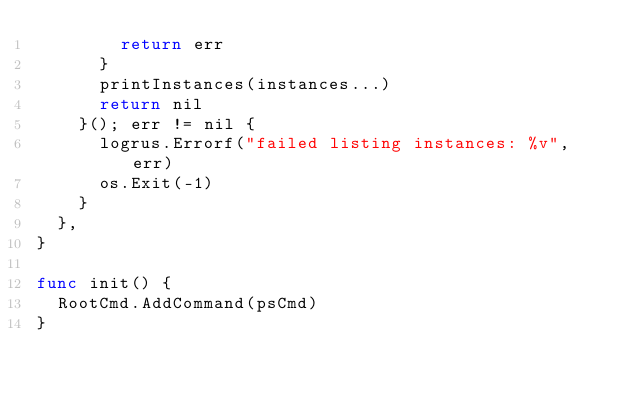<code> <loc_0><loc_0><loc_500><loc_500><_Go_>				return err
			}
			printInstances(instances...)
			return nil
		}(); err != nil {
			logrus.Errorf("failed listing instances: %v", err)
			os.Exit(-1)
		}
	},
}

func init() {
	RootCmd.AddCommand(psCmd)
}
</code> 